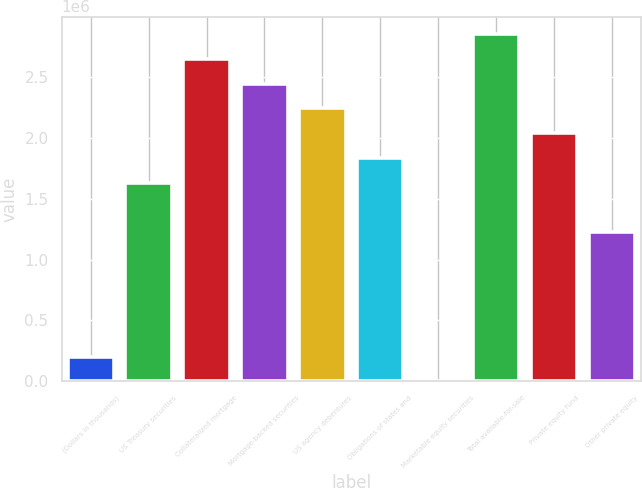<chart> <loc_0><loc_0><loc_500><loc_500><bar_chart><fcel>(Dollars in thousands)<fcel>US Treasury securities<fcel>Collateralized mortgage<fcel>Mortgage-backed securities<fcel>US agency debentures<fcel>Obligations of states and<fcel>Marketable equity securities<fcel>Total available-for-sale<fcel>Private equity fund<fcel>Other private equity<nl><fcel>204297<fcel>1.62994e+06<fcel>2.64826e+06<fcel>2.4446e+06<fcel>2.24093e+06<fcel>1.83361e+06<fcel>633<fcel>2.85192e+06<fcel>2.03727e+06<fcel>1.22262e+06<nl></chart> 